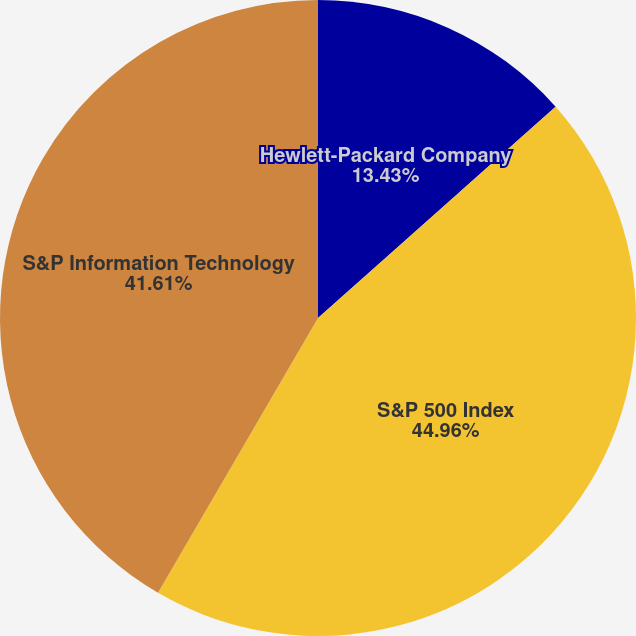Convert chart to OTSL. <chart><loc_0><loc_0><loc_500><loc_500><pie_chart><fcel>Hewlett-Packard Company<fcel>S&P 500 Index<fcel>S&P Information Technology<nl><fcel>13.43%<fcel>44.96%<fcel>41.61%<nl></chart> 